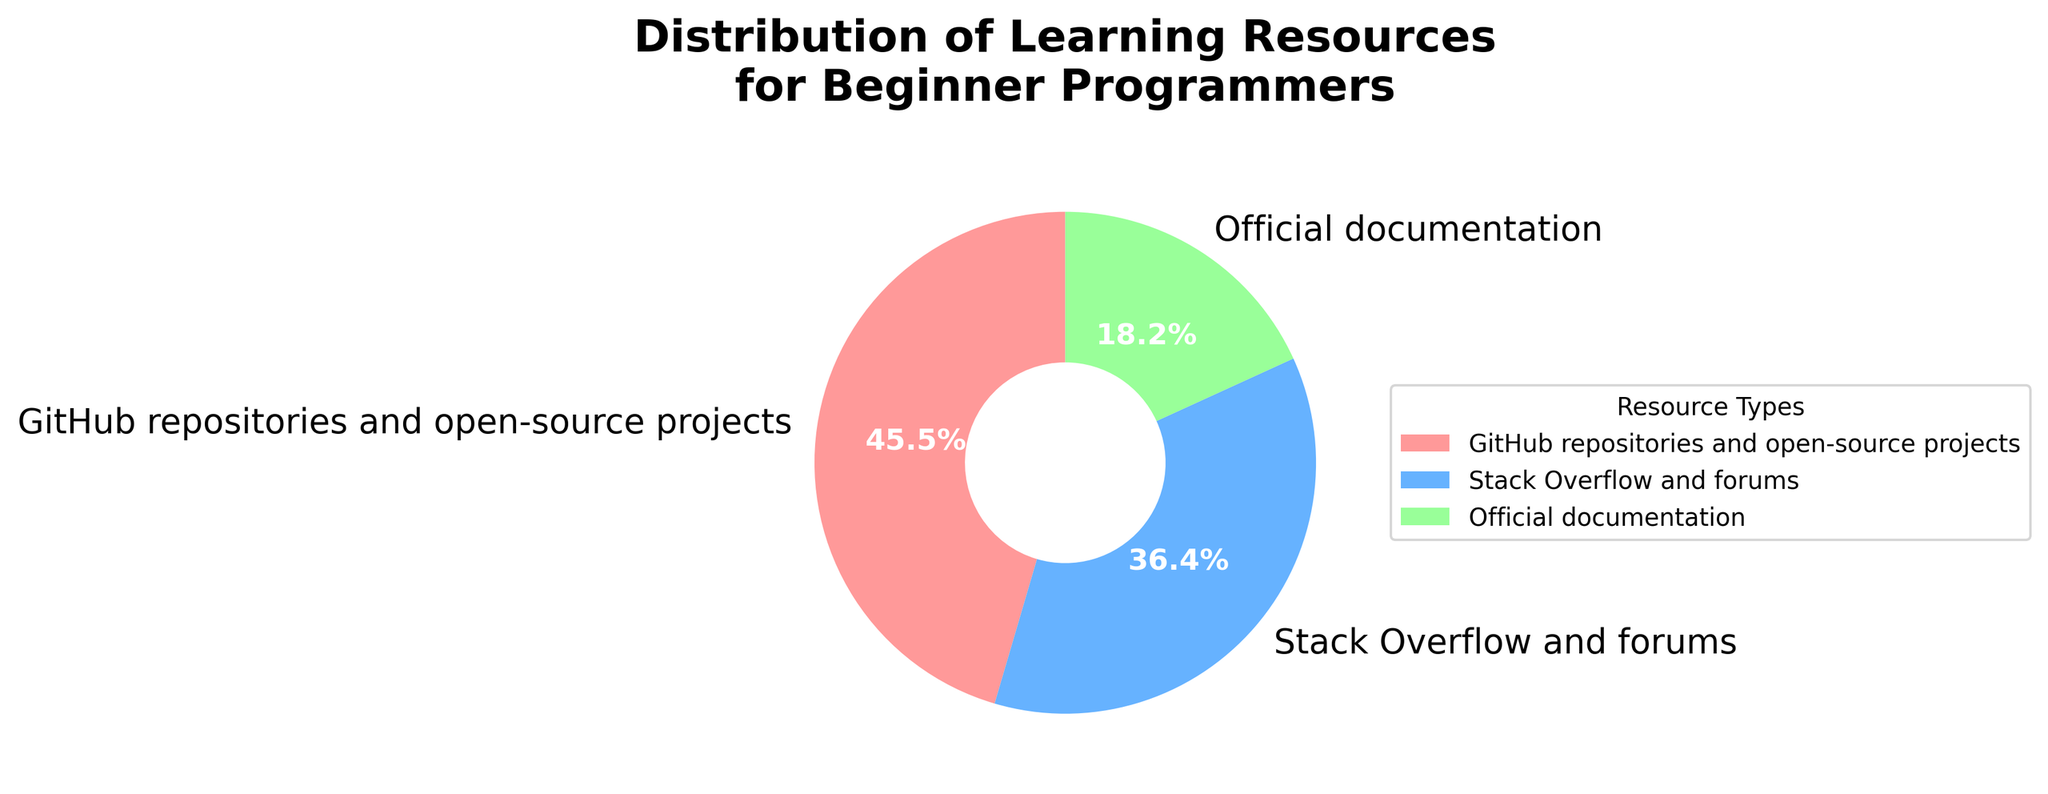Which resource type has the highest percentage of use? The pie chart shows different resource types along with their respective percentages. By looking at the chart, the resource type with the largest section is GitHub repositories and open-source projects.
Answer: GitHub repositories and open-source projects What is the combined percentage of GitHub repositories and Stack Overflow usage? From the chart, GitHub repositories and open-source projects account for 5%, and Stack Overflow and forums account for 4%. Adding these percentages together gives 5% + 4% = 9%.
Answer: 9% Which resource type has the lowest usage percentage? By examining the sizes of the sections in the pie chart, Official documentation is the smallest segment, indicating it has the lowest percentage.
Answer: Official documentation How does the usage of Official documentation compare to GitHub repositories? GitHub repositories and open-source projects have a percentage of 5%, while Official documentation has 2%. Comparing these, GitHub repositories usage (5%) is greater than Official documentation (2%).
Answer: GitHub repositories usage is greater How many percentage points more is Stack Overflow usage compared to Official documentation? Stack Overflow and forums have a usage of 4%, while Official documentation has 2%. Subtracting the two percentages, 4% - 2% = 2%.
Answer: 2 percentage points What is the total percentage represented in the pie chart? Adding up all the percentages: GitHub repositories (5%) + Stack Overflow (4%) + Official documentation (2%) gives a total of 5% + 4% + 2% = 11%.
Answer: 11% What is the percentage difference between the most used and least used resources? The most used resource is GitHub repositories and open-source projects at 5%, and the least used is Official documentation at 2%. The difference is 5% - 2% = 3%.
Answer: 3% What color represents Stack Overflow and forums in the pie chart? The pie chart uses distinct colors for each resource type. Stack Overflow and forums are represented by blue.
Answer: Blue Which segment in the chart is represented by the color green? The pie chart uses distinct colors for each segment, and the green color represents Official documentation.
Answer: Official documentation What percentage does each segment roughly contribute to the total, visually comparing who contributes the smallest portion? By visually inspecting the pie chart, the segment that contributes the smallest portion is the smallest slice, which is Official documentation with a percentage of 2%.
Answer: Official documentation - 2% Explain the proportion of usage between all three resources. Based on the percentages in the chart: GitHub repositories (5%), Stack Overflow (4%), and Official documentation (2%). Calculating their proportion: GitHub repositories take the largest (5/11), followed by Stack Overflow (4/11), and Official documentation the smallest (2/11).
Answer: GitHub repositories > Stack Overflow > Official documentation 